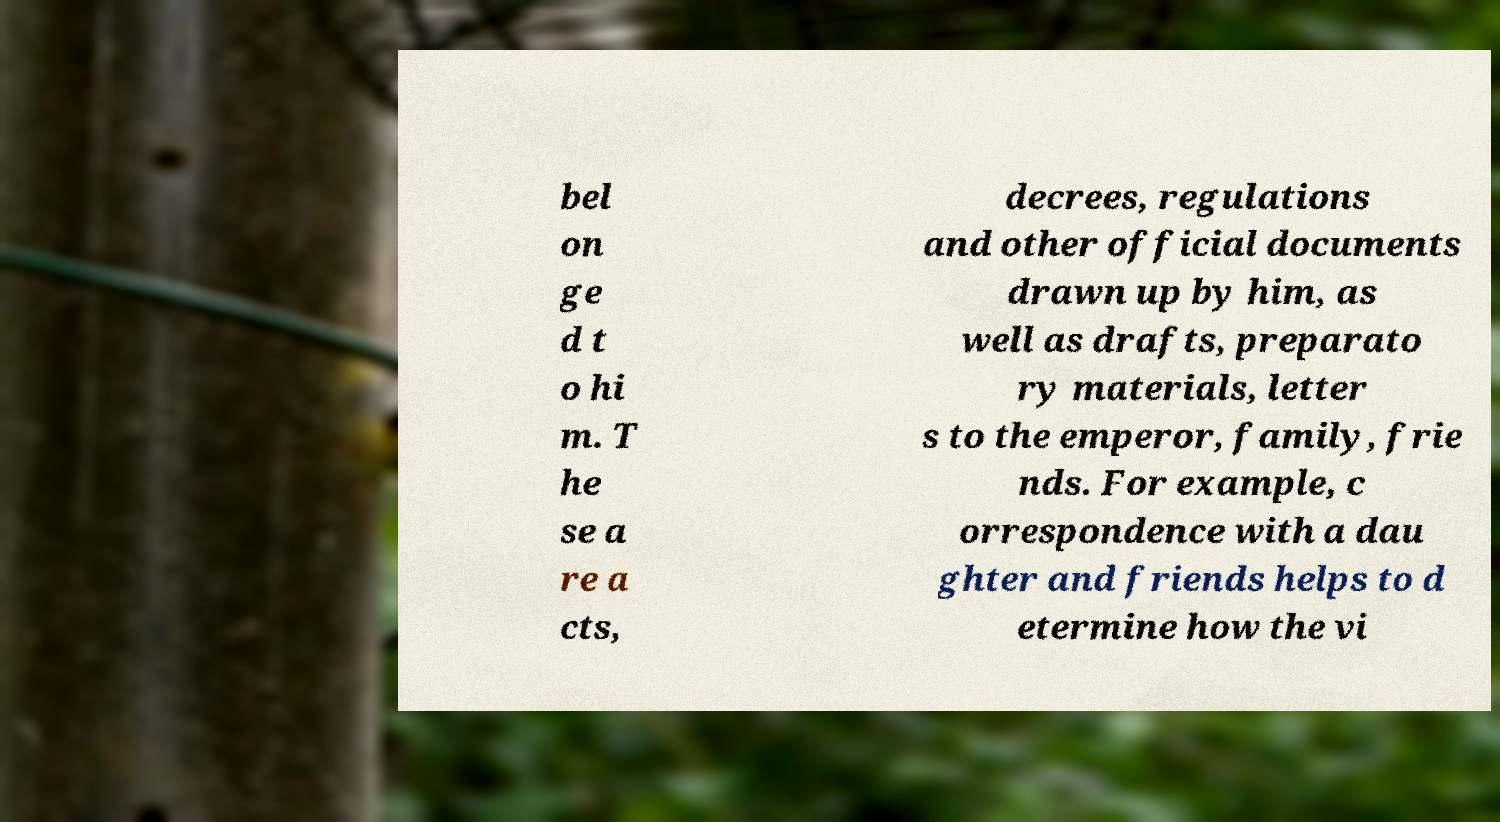Could you extract and type out the text from this image? bel on ge d t o hi m. T he se a re a cts, decrees, regulations and other official documents drawn up by him, as well as drafts, preparato ry materials, letter s to the emperor, family, frie nds. For example, c orrespondence with a dau ghter and friends helps to d etermine how the vi 